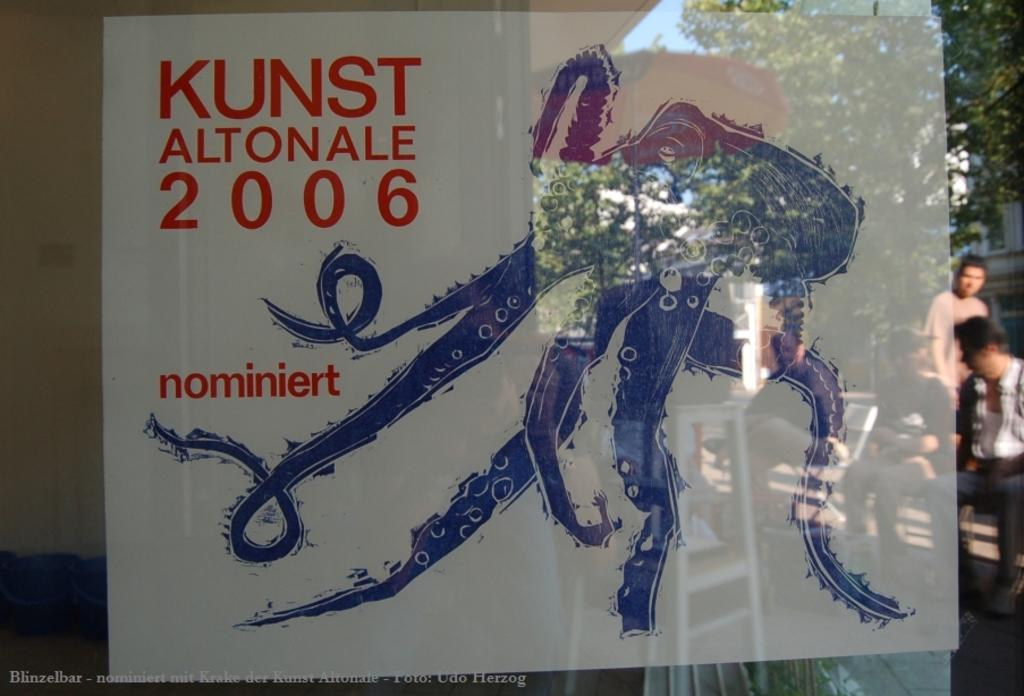<image>
Present a compact description of the photo's key features. An image of an octopus represents Kunst Altonale 2006. 